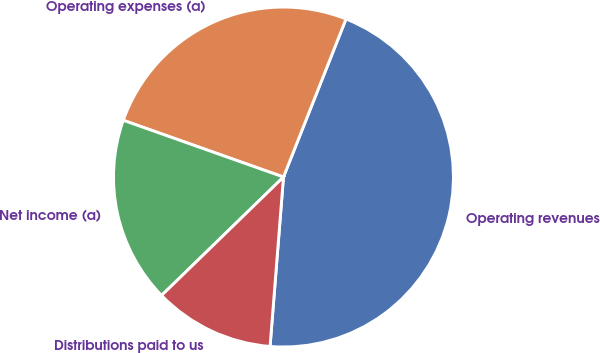Convert chart. <chart><loc_0><loc_0><loc_500><loc_500><pie_chart><fcel>Operating revenues<fcel>Operating expenses (a)<fcel>Net income (a)<fcel>Distributions paid to us<nl><fcel>45.26%<fcel>25.58%<fcel>17.69%<fcel>11.47%<nl></chart> 